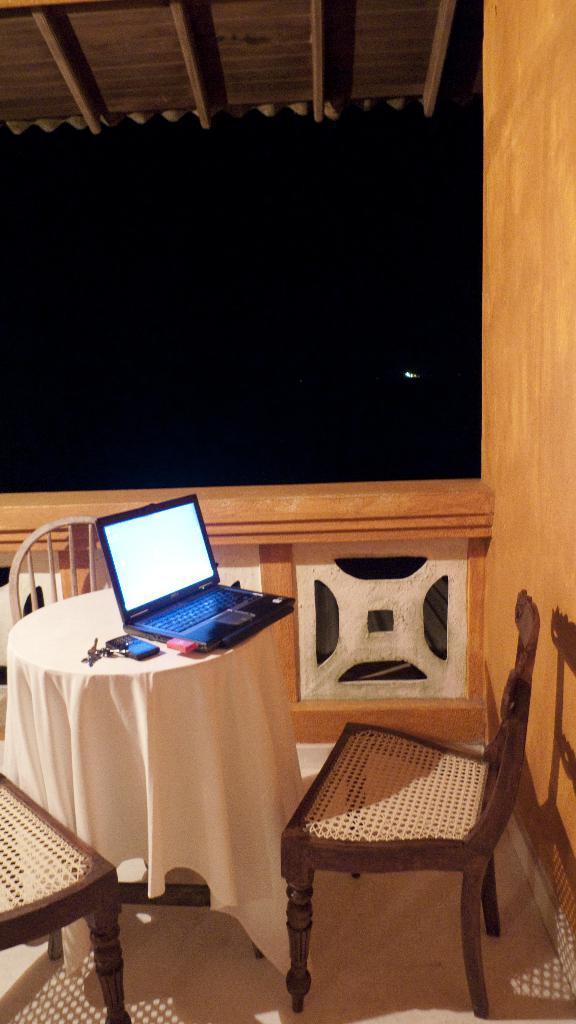In one or two sentences, can you explain what this image depicts? a laptop is present on the table. there are 3 chairs around the table. 